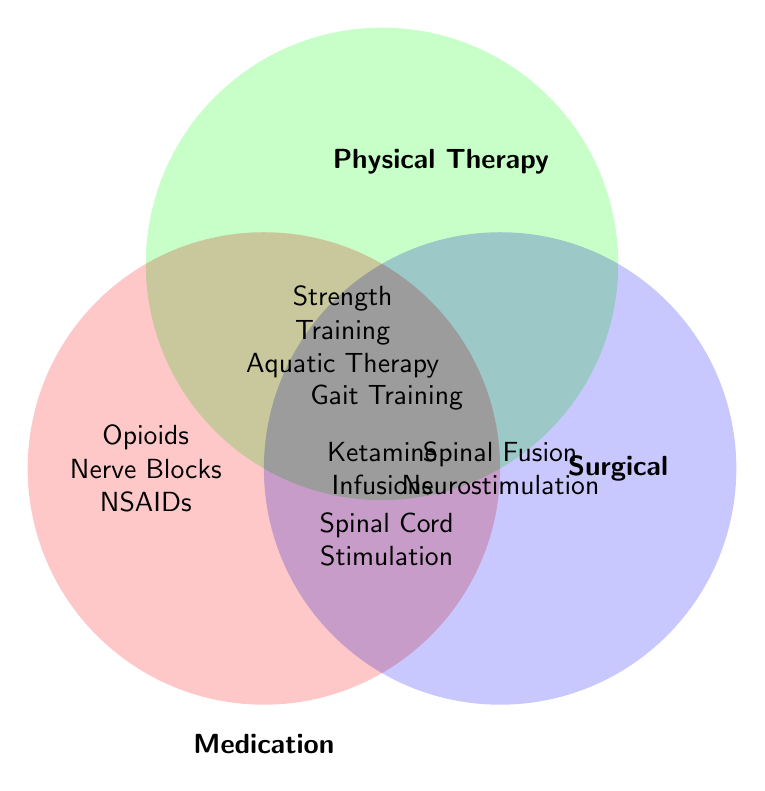What are the three main approaches represented in the Venn Diagram? The figure shows three primary approaches, with each represented by a labeled circle.
Answer: Medication, Physical Therapy, Surgical Which rehabilitation approach includes Aquatic Therapy? Locate the phrase "Aquatic Therapy" in the circle labeled "Physical Therapy".
Answer: Physical Therapy How many specific therapies or treatments are listed under Surgical Interventions? Count the number of entries within the Surgical Interventions circle.
Answer: Five What attributes are common to both Medication Management and Surgical Interventions? Look for overlapping regions between the Medication and Surgical circles.
Answer: Ketamine Infusions Do any therapies or treatments overlap between all three approaches? Check the overlapping region where all three circles intersect.
Answer: None Which approach includes Spinal Fusion? Locate "Spinal Fusion" within the labeled circles in the Venn Diagram.
Answer: Surgical Compare the number of items listed under Physical Therapy to those under Medication Management. Which has more? Count the items in each circle and compare the totals. Physical Therapy has six while Medication Management has seven.
Answer: Medication Management Are there any treatments under Physical Therapy that are also listed under Surgical Interventions? Examine the overlapping sections between Physical Therapy and Surgical Interventions, none are found.
Answer: No Is Range of Motion Exercises exclusive to Physical Therapy? Find "Range of Motion Exercises" in the figure and see if it overlaps with another circle. It does not.
Answer: Yes Identify one therapy from each approach that does not overlap with any other approaches. Locate therapies/treatments entirely within each circle.
Answer: Opioids (Medication), Strength Training (Physical Therapy), Spinal Fusion (Surgical) 